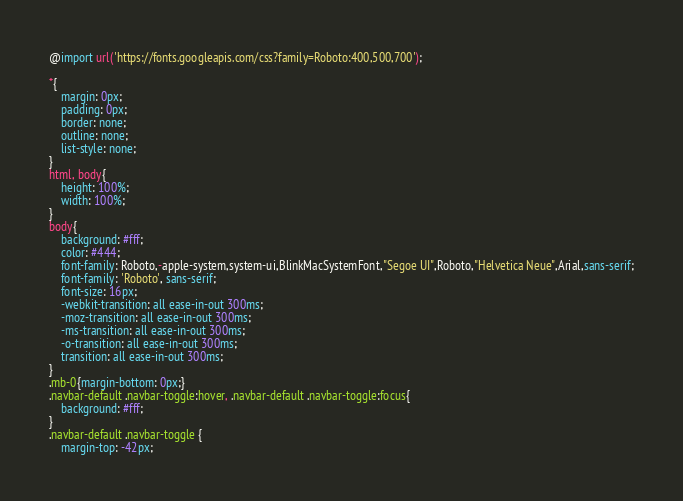Convert code to text. <code><loc_0><loc_0><loc_500><loc_500><_CSS_>@import url('https://fonts.googleapis.com/css?family=Roboto:400,500,700');

*{
    margin: 0px;
    padding: 0px;
    border: none;
    outline: none;
    list-style: none;
}
html, body{
    height: 100%;
    width: 100%;
}
body{
    background: #fff;
    color: #444;
    font-family: Roboto,-apple-system,system-ui,BlinkMacSystemFont,"Segoe UI",Roboto,"Helvetica Neue",Arial,sans-serif;
    font-family: 'Roboto', sans-serif;
    font-size: 16px;
    -webkit-transition: all ease-in-out 300ms;
    -moz-transition: all ease-in-out 300ms;
    -ms-transition: all ease-in-out 300ms;
    -o-transition: all ease-in-out 300ms;
    transition: all ease-in-out 300ms;
}
.mb-0{margin-bottom: 0px;}
.navbar-default .navbar-toggle:hover, .navbar-default .navbar-toggle:focus{
    background: #fff;
}
.navbar-default .navbar-toggle {
    margin-top: -42px;</code> 